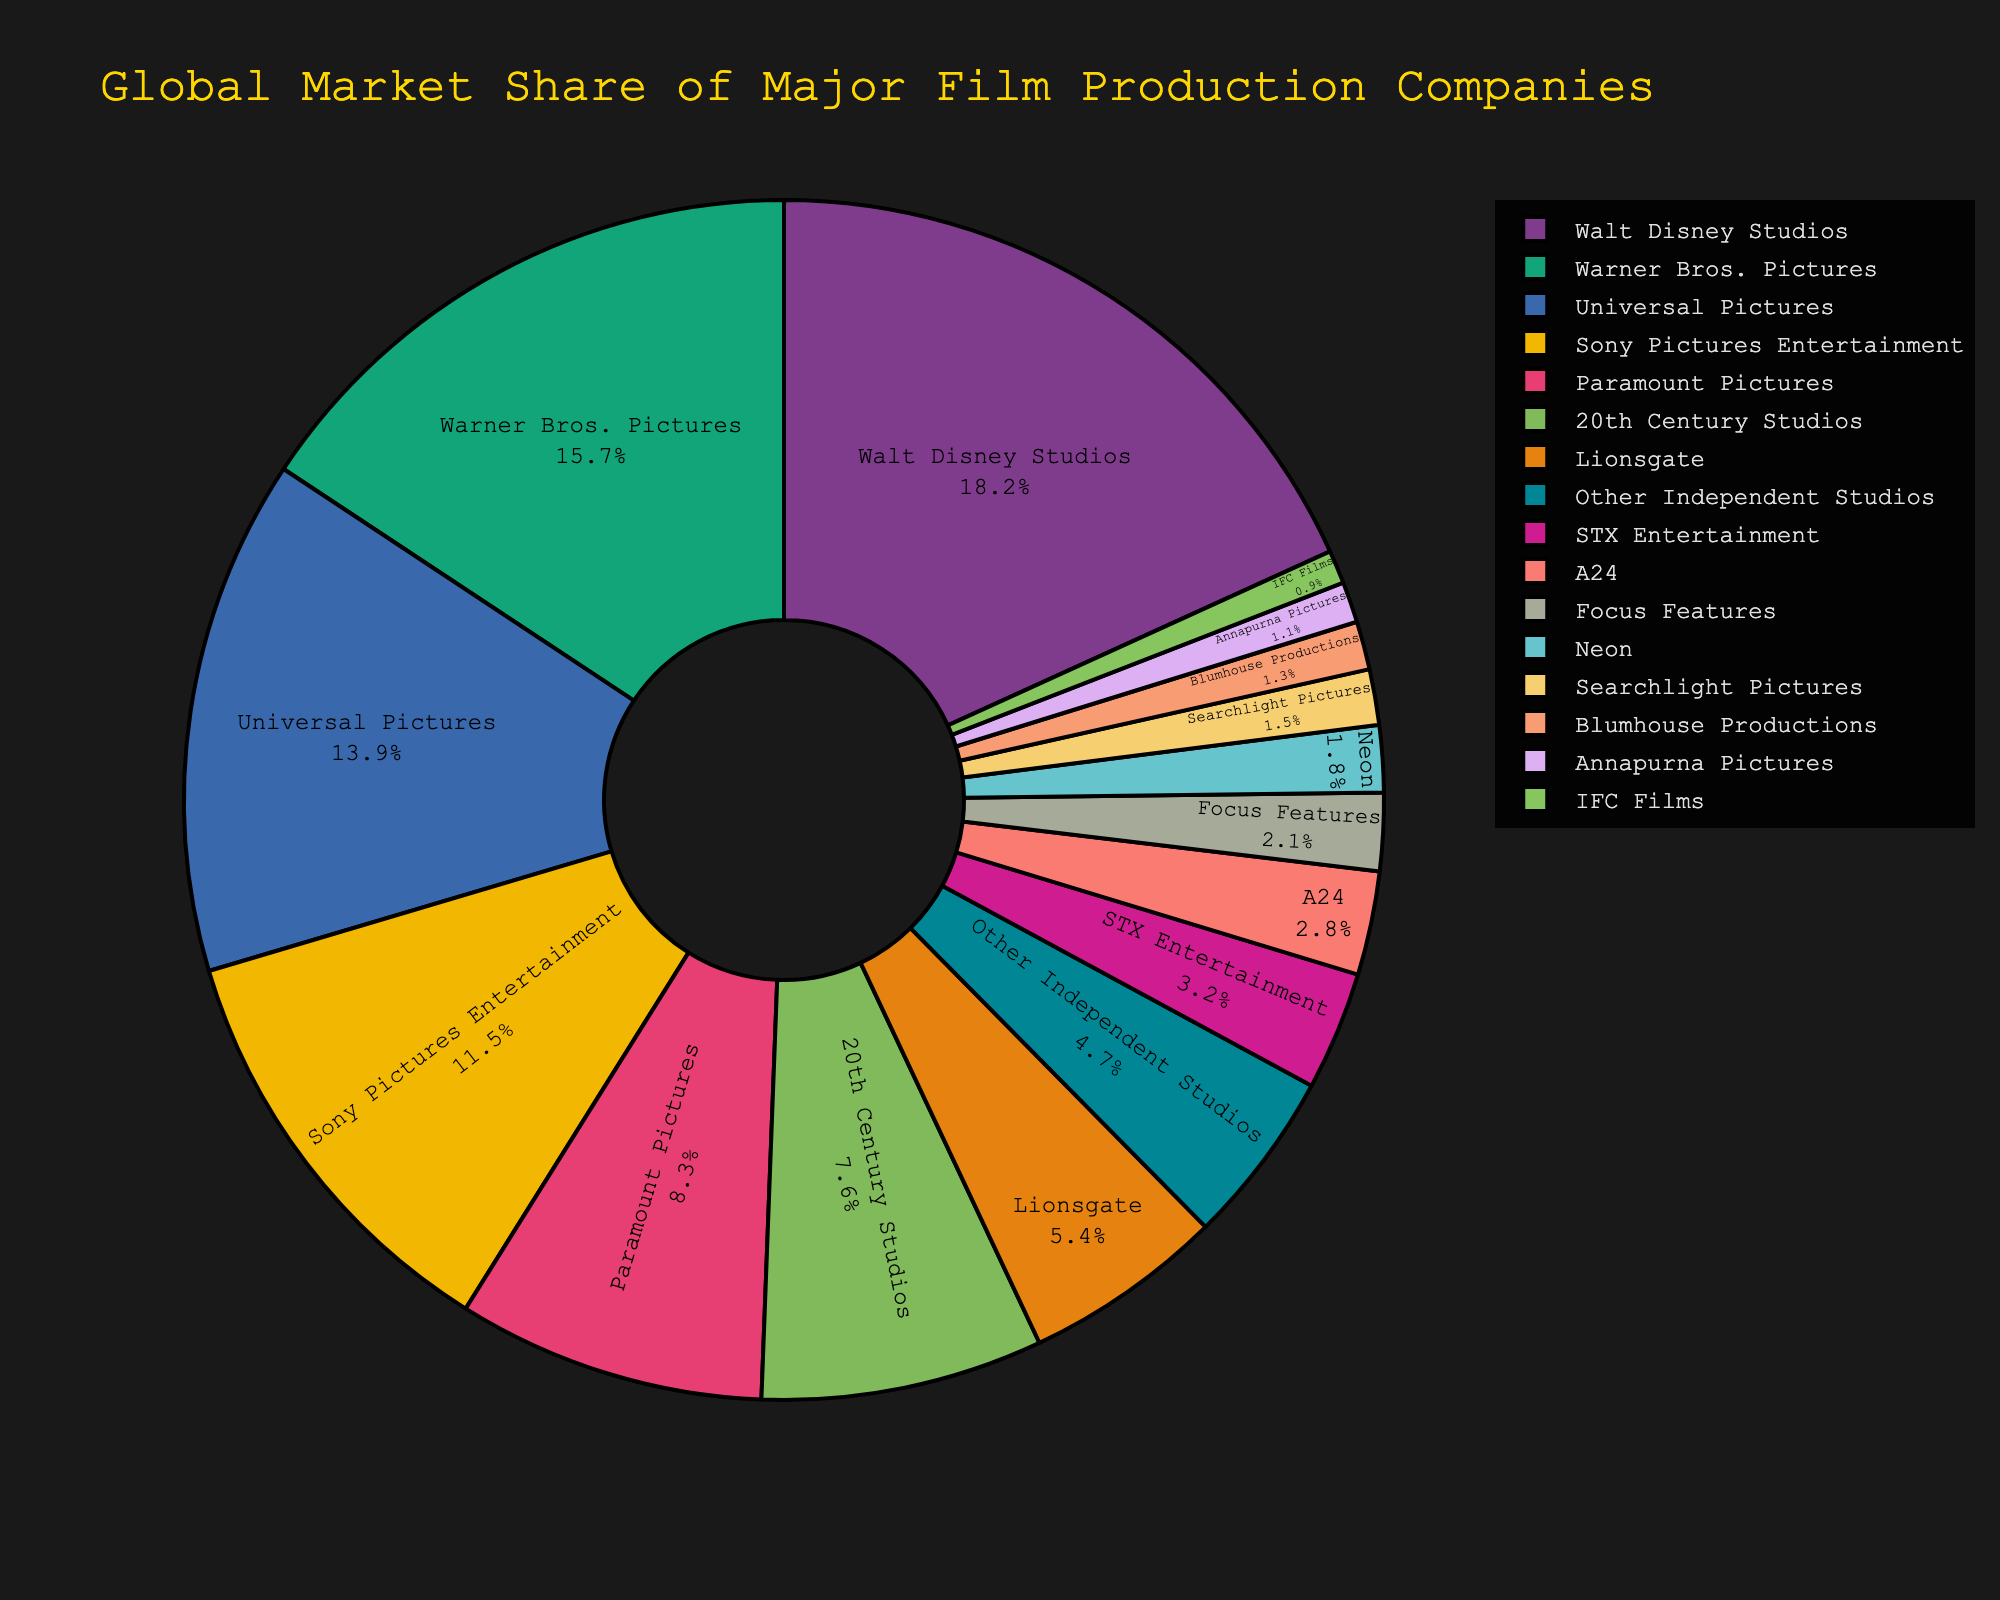What's the market share of Walt Disney Studios? The pie chart shows Walt Disney Studios with the largest section. According to the legend, its market share is 18.2%.
Answer: 18.2% Which company has a higher market share, Warner Bros. Pictures or Universal Pictures? By examining the size of the respective sections and the legend, Warner Bros. Pictures has 15.7% while Universal Pictures has 13.9%.
Answer: Warner Bros. Pictures Sum the market shares of Sony Pictures Entertainment and Paramount Pictures. Sony Pictures Entertainment has 11.5% and Paramount Pictures has 8.3%. Adding them together: 11.5 + 8.3 = 19.8%.
Answer: 19.8% Is Lionsgate's market share greater than the combined market share of STX Entertainment and A24? Lionsgate has a market share of 5.4%. The combined market share of STX Entertainment (3.2%) and A24 (2.8%) is 6.0%. 5.4% < 6.0%, so Liongate's share is not greater.
Answer: No Which company has the smallest market share? By looking at the smallest pie chart section and referencing the legend, IFC Films has the smallest market share at 0.9%.
Answer: IFC Films What's the combined market share of the bottom three companies in the chart? The bottom three companies are Searchlight Pictures (1.5%), Blumhouse Productions (1.3%), and Annapurna Pictures (1.1%). Summing these: 1.5 + 1.3 + 1.1 = 3.9%.
Answer: 3.9% What is the market share of the "Other Independent Studios" category? In the legend and corresponding section, the market share for "Other Independent Studios" is 4.7%.
Answer: 4.7% Is the market share of 20th Century Studios more than double that of Neon? 20th Century Studios has a market share of 7.6%. Neon has a market share of 1.8%. Doubling Neon's share: 2 * 1.8 = 3.6%. Since 7.6% > 3.6%, 20th Century Studios' share is more than double that of Neon.
Answer: Yes How many companies have a market share greater than 10%? Examining the legend, the companies with a market share greater than 10% are Walt Disney Studios, Warner Bros. Pictures, Universal Pictures, and Sony Pictures Entertainment. There are 4 such companies.
Answer: 4 What percent of the total market share is held by the top three companies? The top three companies are Walt Disney Studios (18.2%), Warner Bros. Pictures (15.7%), and Universal Pictures (13.9%). Summing these: 18.2 + 15.7 + 13.9 = 47.8%.
Answer: 47.8% 